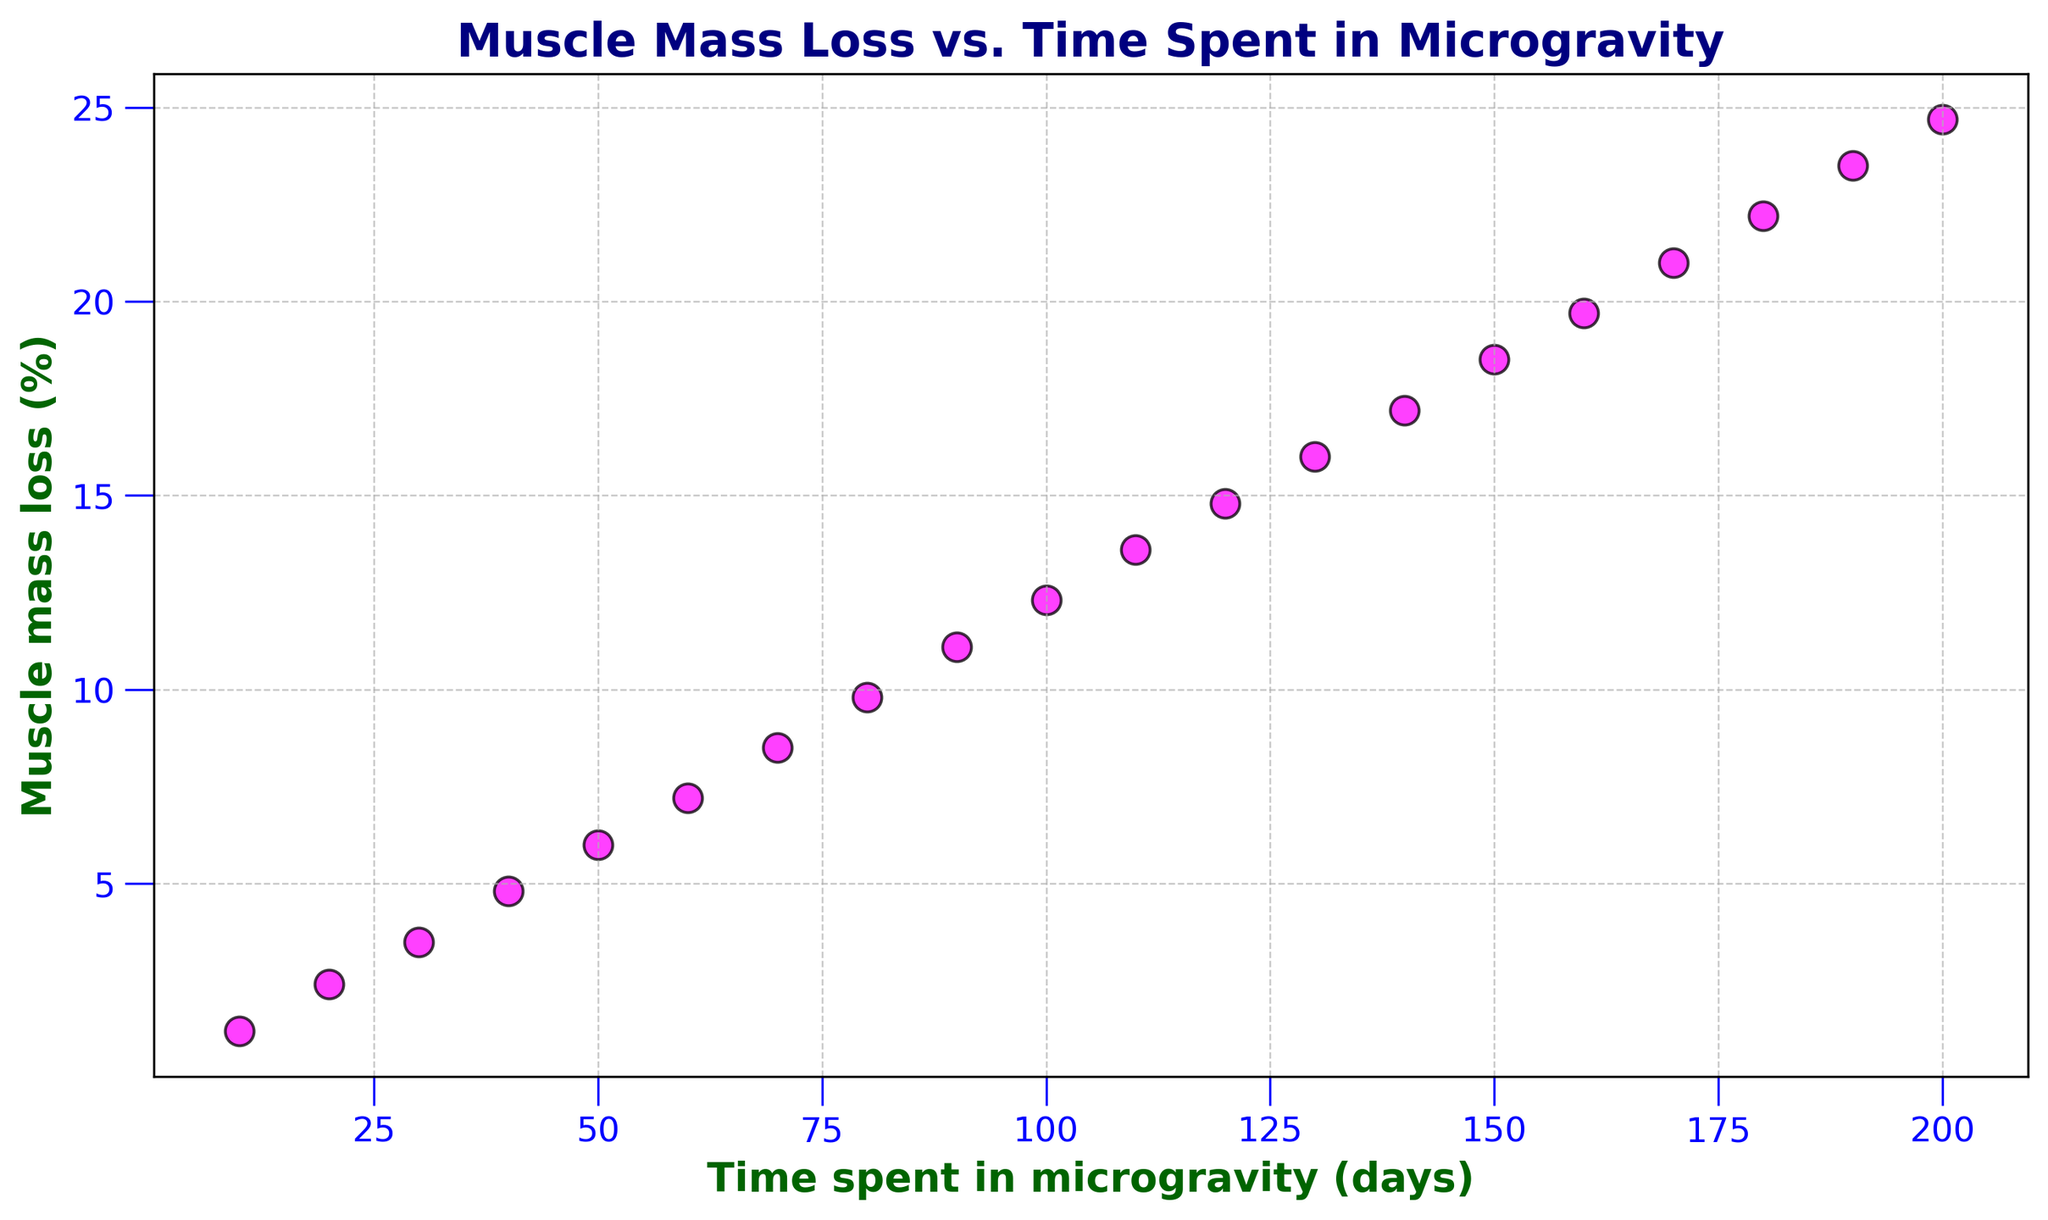What is the muscle mass loss after 100 days in microgravity? Locate the data point where the x-axis (Time spent in microgravity) is 100 days and read the y-axis value associated with it.
Answer: 12.3% How much more muscle mass loss is observed at 90 days compared to 40 days? Find the muscle mass loss at 90 days and 40 days. The values are 11.1% and 4.8%, respectively. Calculate the difference: 11.1 - 4.8.
Answer: 6.3% What is the median muscle mass loss for the given time points? To find the median, list the muscle mass loss values and identify the middle value. The values are: 1.2, 2.4, 3.5, 4.8, 6.0, 7.2, 8.5, 9.8, 11.1, 12.3, 13.6, 14.8, 16.0, 17.2, 18.5, 19.7, 21.0, 22.2, 23.5, 24.7. The median is the average of the 10th and 11th values: (12.3 + 13.6)/2.
Answer: 12.95% If astronaut A spent 160 days in microgravity and astronaut B spent 80 days, how much more muscle mass loss does astronaut A experience compared to astronaut B? Find muscle mass loss at 160 and 80 days. The values are 19.7% and 9.8%, respectively. Calculate the difference: 19.7 - 9.8.
Answer: 9.9% Is the muscle mass loss linear with respect to time spent in microgravity? Examine if the points on the scatter plot form a straight line by comparing the increments of muscle mass loss over equal time intervals. For example, every 20 days, the muscle mass loss increases by about 2.4%. The approximately constant rate suggests linearity.
Answer: Yes What visual elements indicate the trend in muscle mass loss over time? The scatter plot shows magenta data points with black edges. As the x-axis (time) increases, the y-axis (muscle mass loss) consistently increases, indicating an upward trend. The grid and axis labels enhance clarity.
Answer: Magenta points and upward trend How much muscle mass loss is there at the midpoint of 150 and 190 days? Calculate the midpoint: (150+190)/2 = 170 days. Find the muscle mass loss at 170 days from the plot, which is 21.0%.
Answer: 21.0% Between 50 and 150 days, which period shows a steeper increase in muscle mass loss: 50 to 100 days or 100 to 150 days? Calculate the increase for both periods. From 50 to 100 days, the muscle mass loss increase is 12.3% - 6.0% = 6.3%. From 100 to 150 days, the increase is 18.5% - 12.3% = 6.2%. Compare 6.3% and 6.2%.
Answer: 50 to 100 days 